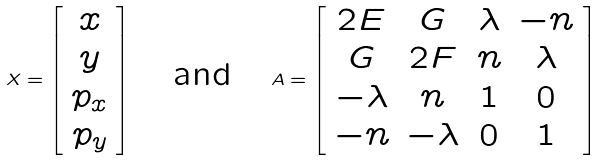<formula> <loc_0><loc_0><loc_500><loc_500>X = \left [ \begin{array} { c } x \\ y \\ p _ { x } \\ p _ { y } \end{array} \right ] \quad \text {and} \quad A = \left [ \begin{array} { c c c c } 2 E & G & \lambda & - n \\ G & 2 F & n & \lambda \\ - \lambda & n & 1 & 0 \\ - n & - \lambda & 0 & 1 \end{array} \right ]</formula> 